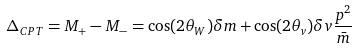Convert formula to latex. <formula><loc_0><loc_0><loc_500><loc_500>\Delta _ { C P T } = M _ { + } - M _ { - } = \cos ( 2 \theta _ { W } ) \delta m + \cos ( 2 \theta _ { v } ) \delta v \frac { p ^ { 2 } } { \bar { m } }</formula> 